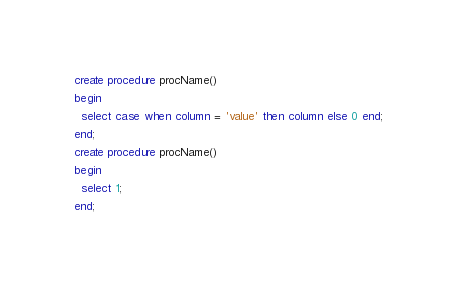<code> <loc_0><loc_0><loc_500><loc_500><_SQL_>create procedure procName()
begin
  select case when column = 'value' then column else 0 end;
end;
create procedure procName()
begin
  select 1;
end;
</code> 